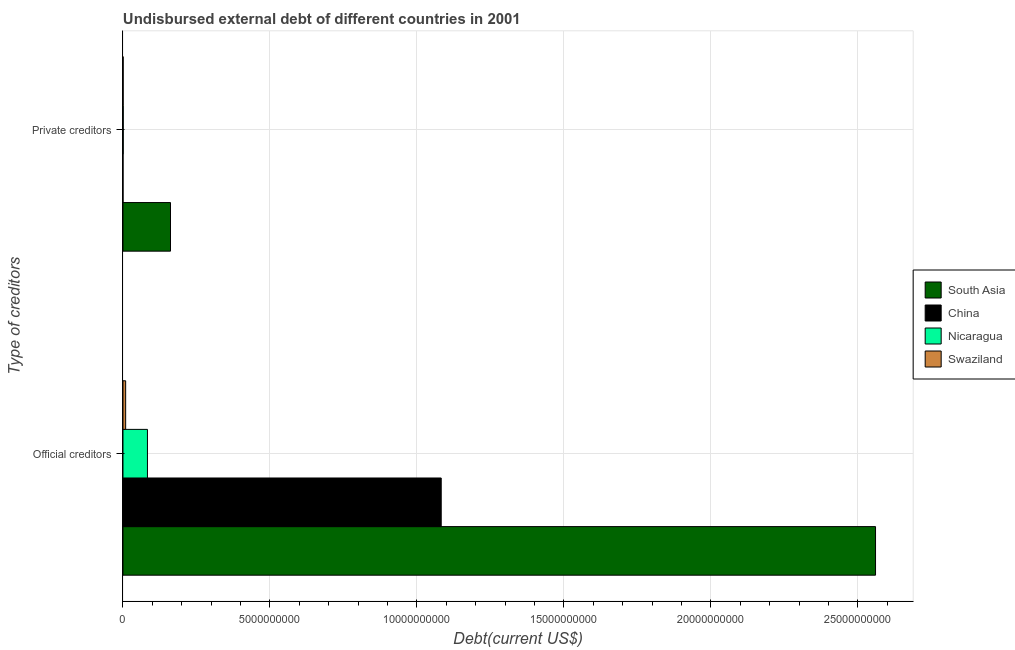How many groups of bars are there?
Keep it short and to the point. 2. Are the number of bars per tick equal to the number of legend labels?
Offer a terse response. Yes. How many bars are there on the 1st tick from the top?
Keep it short and to the point. 4. How many bars are there on the 1st tick from the bottom?
Offer a very short reply. 4. What is the label of the 1st group of bars from the top?
Ensure brevity in your answer.  Private creditors. What is the undisbursed external debt of private creditors in Swaziland?
Provide a short and direct response. 5.44e+06. Across all countries, what is the maximum undisbursed external debt of private creditors?
Offer a very short reply. 1.62e+09. Across all countries, what is the minimum undisbursed external debt of private creditors?
Keep it short and to the point. 1.89e+05. In which country was the undisbursed external debt of official creditors minimum?
Provide a succinct answer. Swaziland. What is the total undisbursed external debt of private creditors in the graph?
Provide a short and direct response. 1.63e+09. What is the difference between the undisbursed external debt of private creditors in South Asia and that in Swaziland?
Make the answer very short. 1.61e+09. What is the difference between the undisbursed external debt of private creditors in South Asia and the undisbursed external debt of official creditors in Nicaragua?
Your answer should be compact. 7.84e+08. What is the average undisbursed external debt of official creditors per country?
Make the answer very short. 9.34e+09. What is the difference between the undisbursed external debt of private creditors and undisbursed external debt of official creditors in South Asia?
Provide a short and direct response. -2.40e+1. In how many countries, is the undisbursed external debt of official creditors greater than 13000000000 US$?
Your answer should be very brief. 1. What is the ratio of the undisbursed external debt of official creditors in South Asia to that in Swaziland?
Ensure brevity in your answer.  281.33. In how many countries, is the undisbursed external debt of official creditors greater than the average undisbursed external debt of official creditors taken over all countries?
Offer a terse response. 2. What does the 4th bar from the bottom in Official creditors represents?
Offer a very short reply. Swaziland. Are all the bars in the graph horizontal?
Keep it short and to the point. Yes. How many countries are there in the graph?
Your answer should be very brief. 4. What is the difference between two consecutive major ticks on the X-axis?
Your response must be concise. 5.00e+09. Are the values on the major ticks of X-axis written in scientific E-notation?
Offer a terse response. No. How many legend labels are there?
Provide a succinct answer. 4. How are the legend labels stacked?
Your answer should be compact. Vertical. What is the title of the graph?
Your answer should be very brief. Undisbursed external debt of different countries in 2001. Does "Estonia" appear as one of the legend labels in the graph?
Keep it short and to the point. No. What is the label or title of the X-axis?
Offer a terse response. Debt(current US$). What is the label or title of the Y-axis?
Give a very brief answer. Type of creditors. What is the Debt(current US$) of South Asia in Official creditors?
Your answer should be compact. 2.56e+1. What is the Debt(current US$) in China in Official creditors?
Make the answer very short. 1.08e+1. What is the Debt(current US$) of Nicaragua in Official creditors?
Ensure brevity in your answer.  8.32e+08. What is the Debt(current US$) in Swaziland in Official creditors?
Provide a succinct answer. 9.10e+07. What is the Debt(current US$) in South Asia in Private creditors?
Your answer should be compact. 1.62e+09. What is the Debt(current US$) in China in Private creditors?
Give a very brief answer. 1.89e+05. What is the Debt(current US$) of Nicaragua in Private creditors?
Provide a short and direct response. 8.91e+06. What is the Debt(current US$) in Swaziland in Private creditors?
Offer a very short reply. 5.44e+06. Across all Type of creditors, what is the maximum Debt(current US$) of South Asia?
Give a very brief answer. 2.56e+1. Across all Type of creditors, what is the maximum Debt(current US$) of China?
Offer a very short reply. 1.08e+1. Across all Type of creditors, what is the maximum Debt(current US$) in Nicaragua?
Your answer should be very brief. 8.32e+08. Across all Type of creditors, what is the maximum Debt(current US$) in Swaziland?
Ensure brevity in your answer.  9.10e+07. Across all Type of creditors, what is the minimum Debt(current US$) of South Asia?
Your answer should be very brief. 1.62e+09. Across all Type of creditors, what is the minimum Debt(current US$) of China?
Give a very brief answer. 1.89e+05. Across all Type of creditors, what is the minimum Debt(current US$) of Nicaragua?
Ensure brevity in your answer.  8.91e+06. Across all Type of creditors, what is the minimum Debt(current US$) of Swaziland?
Make the answer very short. 5.44e+06. What is the total Debt(current US$) of South Asia in the graph?
Provide a short and direct response. 2.72e+1. What is the total Debt(current US$) of China in the graph?
Your answer should be compact. 1.08e+1. What is the total Debt(current US$) of Nicaragua in the graph?
Offer a very short reply. 8.41e+08. What is the total Debt(current US$) in Swaziland in the graph?
Provide a succinct answer. 9.64e+07. What is the difference between the Debt(current US$) in South Asia in Official creditors and that in Private creditors?
Offer a very short reply. 2.40e+1. What is the difference between the Debt(current US$) of China in Official creditors and that in Private creditors?
Your response must be concise. 1.08e+1. What is the difference between the Debt(current US$) in Nicaragua in Official creditors and that in Private creditors?
Keep it short and to the point. 8.23e+08. What is the difference between the Debt(current US$) in Swaziland in Official creditors and that in Private creditors?
Your answer should be very brief. 8.55e+07. What is the difference between the Debt(current US$) in South Asia in Official creditors and the Debt(current US$) in China in Private creditors?
Your answer should be very brief. 2.56e+1. What is the difference between the Debt(current US$) in South Asia in Official creditors and the Debt(current US$) in Nicaragua in Private creditors?
Offer a very short reply. 2.56e+1. What is the difference between the Debt(current US$) in South Asia in Official creditors and the Debt(current US$) in Swaziland in Private creditors?
Your answer should be compact. 2.56e+1. What is the difference between the Debt(current US$) in China in Official creditors and the Debt(current US$) in Nicaragua in Private creditors?
Give a very brief answer. 1.08e+1. What is the difference between the Debt(current US$) in China in Official creditors and the Debt(current US$) in Swaziland in Private creditors?
Your answer should be compact. 1.08e+1. What is the difference between the Debt(current US$) of Nicaragua in Official creditors and the Debt(current US$) of Swaziland in Private creditors?
Your answer should be very brief. 8.27e+08. What is the average Debt(current US$) in South Asia per Type of creditors?
Provide a succinct answer. 1.36e+1. What is the average Debt(current US$) in China per Type of creditors?
Provide a short and direct response. 5.41e+09. What is the average Debt(current US$) of Nicaragua per Type of creditors?
Make the answer very short. 4.21e+08. What is the average Debt(current US$) in Swaziland per Type of creditors?
Keep it short and to the point. 4.82e+07. What is the difference between the Debt(current US$) of South Asia and Debt(current US$) of China in Official creditors?
Provide a succinct answer. 1.48e+1. What is the difference between the Debt(current US$) of South Asia and Debt(current US$) of Nicaragua in Official creditors?
Your response must be concise. 2.48e+1. What is the difference between the Debt(current US$) of South Asia and Debt(current US$) of Swaziland in Official creditors?
Your response must be concise. 2.55e+1. What is the difference between the Debt(current US$) in China and Debt(current US$) in Nicaragua in Official creditors?
Your answer should be compact. 9.99e+09. What is the difference between the Debt(current US$) in China and Debt(current US$) in Swaziland in Official creditors?
Make the answer very short. 1.07e+1. What is the difference between the Debt(current US$) of Nicaragua and Debt(current US$) of Swaziland in Official creditors?
Your answer should be very brief. 7.41e+08. What is the difference between the Debt(current US$) of South Asia and Debt(current US$) of China in Private creditors?
Your response must be concise. 1.62e+09. What is the difference between the Debt(current US$) in South Asia and Debt(current US$) in Nicaragua in Private creditors?
Provide a succinct answer. 1.61e+09. What is the difference between the Debt(current US$) in South Asia and Debt(current US$) in Swaziland in Private creditors?
Ensure brevity in your answer.  1.61e+09. What is the difference between the Debt(current US$) in China and Debt(current US$) in Nicaragua in Private creditors?
Keep it short and to the point. -8.72e+06. What is the difference between the Debt(current US$) of China and Debt(current US$) of Swaziland in Private creditors?
Your answer should be compact. -5.25e+06. What is the difference between the Debt(current US$) in Nicaragua and Debt(current US$) in Swaziland in Private creditors?
Your answer should be compact. 3.47e+06. What is the ratio of the Debt(current US$) in South Asia in Official creditors to that in Private creditors?
Give a very brief answer. 15.83. What is the ratio of the Debt(current US$) in China in Official creditors to that in Private creditors?
Your response must be concise. 5.73e+04. What is the ratio of the Debt(current US$) of Nicaragua in Official creditors to that in Private creditors?
Provide a succinct answer. 93.4. What is the ratio of the Debt(current US$) in Swaziland in Official creditors to that in Private creditors?
Your response must be concise. 16.72. What is the difference between the highest and the second highest Debt(current US$) of South Asia?
Keep it short and to the point. 2.40e+1. What is the difference between the highest and the second highest Debt(current US$) of China?
Your answer should be very brief. 1.08e+1. What is the difference between the highest and the second highest Debt(current US$) in Nicaragua?
Offer a very short reply. 8.23e+08. What is the difference between the highest and the second highest Debt(current US$) in Swaziland?
Provide a short and direct response. 8.55e+07. What is the difference between the highest and the lowest Debt(current US$) of South Asia?
Offer a terse response. 2.40e+1. What is the difference between the highest and the lowest Debt(current US$) in China?
Provide a succinct answer. 1.08e+1. What is the difference between the highest and the lowest Debt(current US$) in Nicaragua?
Make the answer very short. 8.23e+08. What is the difference between the highest and the lowest Debt(current US$) of Swaziland?
Provide a succinct answer. 8.55e+07. 